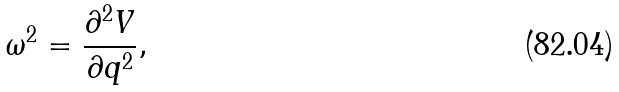<formula> <loc_0><loc_0><loc_500><loc_500>\omega ^ { 2 } = \frac { \partial ^ { 2 } V } { \partial q ^ { 2 } } ,</formula> 